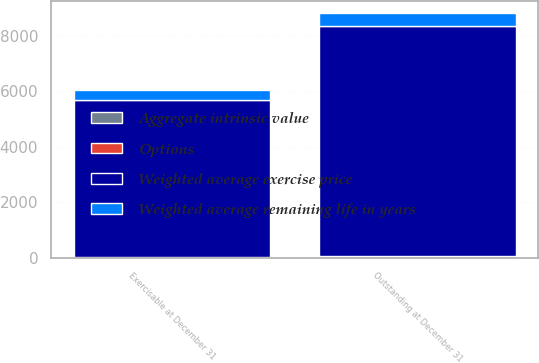Convert chart. <chart><loc_0><loc_0><loc_500><loc_500><stacked_bar_chart><ecel><fcel>Outstanding at December 31<fcel>Exercisable at December 31<nl><fcel>Weighted average exercise price<fcel>8316<fcel>5661<nl><fcel>Aggregate intrinsic value<fcel>41.69<fcel>35.51<nl><fcel>Options<fcel>5.1<fcel>3.6<nl><fcel>Weighted average remaining life in years<fcel>458<fcel>346<nl></chart> 